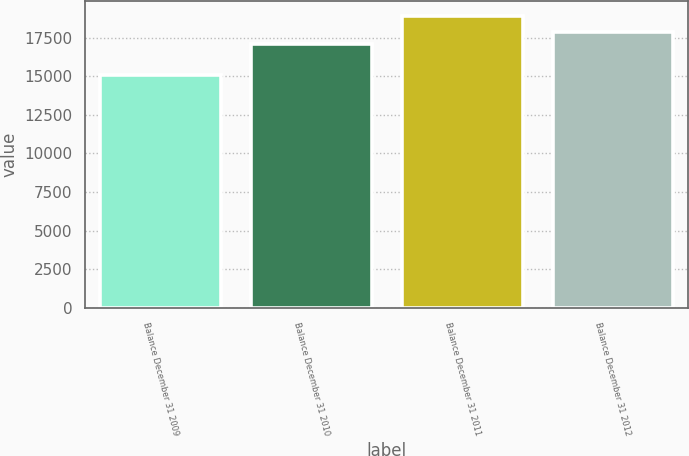Convert chart to OTSL. <chart><loc_0><loc_0><loc_500><loc_500><bar_chart><fcel>Balance December 31 2009<fcel>Balance December 31 2010<fcel>Balance December 31 2011<fcel>Balance December 31 2012<nl><fcel>15093<fcel>17076<fcel>18917<fcel>17860<nl></chart> 